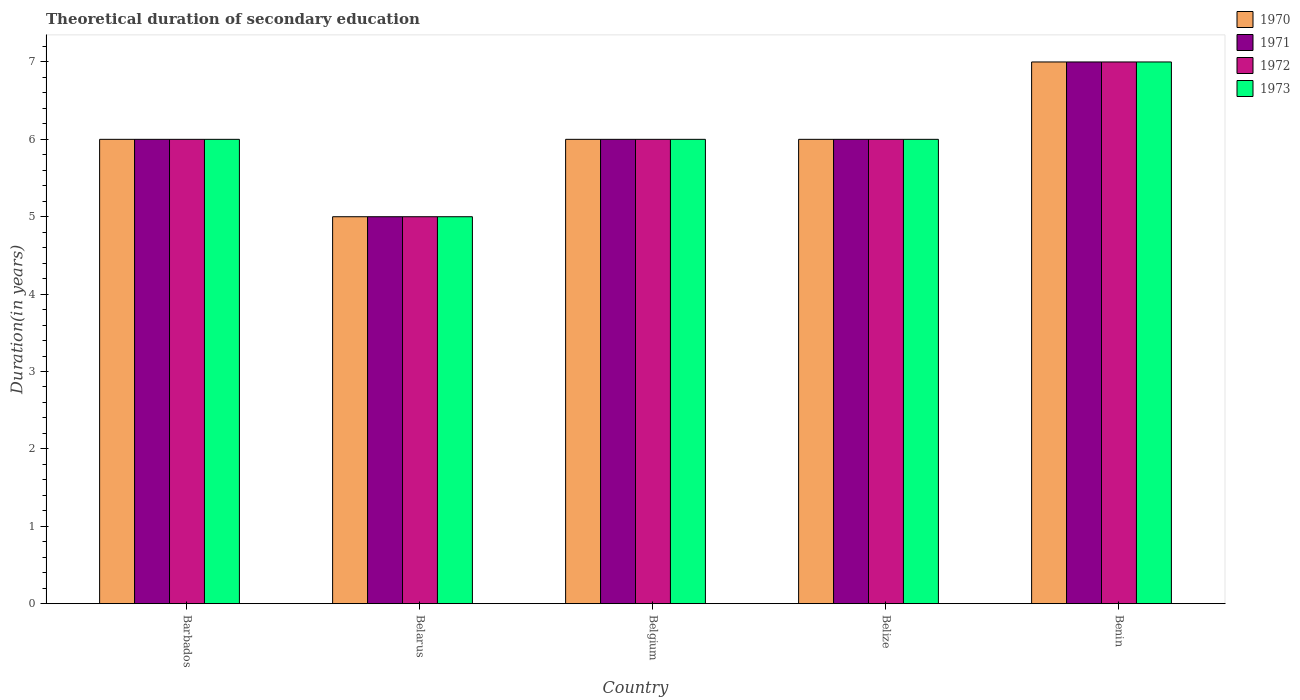How many different coloured bars are there?
Your answer should be very brief. 4. Are the number of bars on each tick of the X-axis equal?
Keep it short and to the point. Yes. How many bars are there on the 3rd tick from the left?
Give a very brief answer. 4. How many bars are there on the 2nd tick from the right?
Provide a short and direct response. 4. What is the label of the 4th group of bars from the left?
Keep it short and to the point. Belize. In how many cases, is the number of bars for a given country not equal to the number of legend labels?
Ensure brevity in your answer.  0. Across all countries, what is the minimum total theoretical duration of secondary education in 1971?
Ensure brevity in your answer.  5. In which country was the total theoretical duration of secondary education in 1971 maximum?
Offer a terse response. Benin. In which country was the total theoretical duration of secondary education in 1971 minimum?
Ensure brevity in your answer.  Belarus. What is the total total theoretical duration of secondary education in 1973 in the graph?
Give a very brief answer. 30. What is the difference between the total theoretical duration of secondary education in 1971 in Belize and that in Benin?
Your answer should be very brief. -1. What is the difference between the total theoretical duration of secondary education in 1971 in Belize and the total theoretical duration of secondary education in 1973 in Benin?
Offer a terse response. -1. What is the average total theoretical duration of secondary education in 1971 per country?
Keep it short and to the point. 6. What is the difference between the total theoretical duration of secondary education of/in 1970 and total theoretical duration of secondary education of/in 1973 in Barbados?
Give a very brief answer. 0. In how many countries, is the total theoretical duration of secondary education in 1972 greater than 1.2 years?
Offer a terse response. 5. What is the ratio of the total theoretical duration of secondary education in 1970 in Belarus to that in Benin?
Provide a short and direct response. 0.71. What is the difference between the highest and the lowest total theoretical duration of secondary education in 1970?
Provide a short and direct response. 2. In how many countries, is the total theoretical duration of secondary education in 1970 greater than the average total theoretical duration of secondary education in 1970 taken over all countries?
Your response must be concise. 1. Is the sum of the total theoretical duration of secondary education in 1973 in Belgium and Benin greater than the maximum total theoretical duration of secondary education in 1970 across all countries?
Provide a short and direct response. Yes. Is it the case that in every country, the sum of the total theoretical duration of secondary education in 1972 and total theoretical duration of secondary education in 1973 is greater than the sum of total theoretical duration of secondary education in 1971 and total theoretical duration of secondary education in 1970?
Your response must be concise. No. What does the 4th bar from the right in Belize represents?
Ensure brevity in your answer.  1970. Are all the bars in the graph horizontal?
Your answer should be compact. No. How many countries are there in the graph?
Keep it short and to the point. 5. What is the difference between two consecutive major ticks on the Y-axis?
Make the answer very short. 1. Where does the legend appear in the graph?
Your response must be concise. Top right. How many legend labels are there?
Your answer should be very brief. 4. What is the title of the graph?
Offer a very short reply. Theoretical duration of secondary education. What is the label or title of the Y-axis?
Offer a terse response. Duration(in years). What is the Duration(in years) of 1970 in Barbados?
Your answer should be compact. 6. What is the Duration(in years) in 1970 in Belarus?
Keep it short and to the point. 5. What is the Duration(in years) in 1972 in Belarus?
Keep it short and to the point. 5. What is the Duration(in years) in 1973 in Belarus?
Provide a short and direct response. 5. What is the Duration(in years) in 1972 in Belgium?
Make the answer very short. 6. What is the Duration(in years) in 1970 in Belize?
Your response must be concise. 6. What is the Duration(in years) of 1971 in Belize?
Your answer should be compact. 6. What is the Duration(in years) of 1970 in Benin?
Ensure brevity in your answer.  7. What is the Duration(in years) in 1973 in Benin?
Offer a terse response. 7. Across all countries, what is the maximum Duration(in years) of 1970?
Your response must be concise. 7. Across all countries, what is the maximum Duration(in years) in 1971?
Ensure brevity in your answer.  7. Across all countries, what is the maximum Duration(in years) of 1973?
Offer a very short reply. 7. What is the total Duration(in years) in 1970 in the graph?
Ensure brevity in your answer.  30. What is the total Duration(in years) of 1971 in the graph?
Make the answer very short. 30. What is the total Duration(in years) of 1973 in the graph?
Give a very brief answer. 30. What is the difference between the Duration(in years) of 1970 in Barbados and that in Belarus?
Make the answer very short. 1. What is the difference between the Duration(in years) in 1972 in Barbados and that in Belarus?
Offer a very short reply. 1. What is the difference between the Duration(in years) of 1973 in Barbados and that in Belarus?
Offer a terse response. 1. What is the difference between the Duration(in years) in 1971 in Barbados and that in Belgium?
Give a very brief answer. 0. What is the difference between the Duration(in years) of 1970 in Barbados and that in Belize?
Provide a succinct answer. 0. What is the difference between the Duration(in years) of 1971 in Barbados and that in Belize?
Your response must be concise. 0. What is the difference between the Duration(in years) of 1972 in Barbados and that in Belize?
Your answer should be compact. 0. What is the difference between the Duration(in years) of 1970 in Barbados and that in Benin?
Provide a succinct answer. -1. What is the difference between the Duration(in years) in 1972 in Barbados and that in Benin?
Give a very brief answer. -1. What is the difference between the Duration(in years) of 1973 in Barbados and that in Benin?
Keep it short and to the point. -1. What is the difference between the Duration(in years) of 1971 in Belarus and that in Belgium?
Your response must be concise. -1. What is the difference between the Duration(in years) of 1970 in Belarus and that in Belize?
Provide a short and direct response. -1. What is the difference between the Duration(in years) in 1971 in Belarus and that in Belize?
Your answer should be very brief. -1. What is the difference between the Duration(in years) of 1972 in Belarus and that in Belize?
Provide a succinct answer. -1. What is the difference between the Duration(in years) of 1971 in Belarus and that in Benin?
Provide a short and direct response. -2. What is the difference between the Duration(in years) in 1973 in Belarus and that in Benin?
Ensure brevity in your answer.  -2. What is the difference between the Duration(in years) in 1970 in Belgium and that in Belize?
Make the answer very short. 0. What is the difference between the Duration(in years) of 1971 in Belgium and that in Benin?
Your answer should be compact. -1. What is the difference between the Duration(in years) of 1970 in Belize and that in Benin?
Offer a very short reply. -1. What is the difference between the Duration(in years) of 1972 in Belize and that in Benin?
Keep it short and to the point. -1. What is the difference between the Duration(in years) in 1973 in Belize and that in Benin?
Offer a terse response. -1. What is the difference between the Duration(in years) of 1970 in Barbados and the Duration(in years) of 1971 in Belarus?
Provide a succinct answer. 1. What is the difference between the Duration(in years) in 1970 in Barbados and the Duration(in years) in 1973 in Belarus?
Your answer should be very brief. 1. What is the difference between the Duration(in years) of 1971 in Barbados and the Duration(in years) of 1973 in Belarus?
Provide a succinct answer. 1. What is the difference between the Duration(in years) in 1970 in Barbados and the Duration(in years) in 1972 in Belgium?
Keep it short and to the point. 0. What is the difference between the Duration(in years) of 1971 in Barbados and the Duration(in years) of 1972 in Belgium?
Provide a succinct answer. 0. What is the difference between the Duration(in years) of 1970 in Barbados and the Duration(in years) of 1971 in Belize?
Provide a succinct answer. 0. What is the difference between the Duration(in years) of 1971 in Barbados and the Duration(in years) of 1973 in Belize?
Provide a short and direct response. 0. What is the difference between the Duration(in years) in 1972 in Barbados and the Duration(in years) in 1973 in Belize?
Give a very brief answer. 0. What is the difference between the Duration(in years) of 1970 in Barbados and the Duration(in years) of 1971 in Benin?
Provide a short and direct response. -1. What is the difference between the Duration(in years) in 1970 in Barbados and the Duration(in years) in 1972 in Benin?
Your answer should be very brief. -1. What is the difference between the Duration(in years) in 1970 in Barbados and the Duration(in years) in 1973 in Benin?
Offer a terse response. -1. What is the difference between the Duration(in years) of 1971 in Barbados and the Duration(in years) of 1973 in Benin?
Keep it short and to the point. -1. What is the difference between the Duration(in years) in 1970 in Belarus and the Duration(in years) in 1971 in Belgium?
Provide a succinct answer. -1. What is the difference between the Duration(in years) in 1970 in Belarus and the Duration(in years) in 1972 in Belgium?
Offer a very short reply. -1. What is the difference between the Duration(in years) of 1971 in Belarus and the Duration(in years) of 1973 in Belize?
Provide a succinct answer. -1. What is the difference between the Duration(in years) in 1972 in Belarus and the Duration(in years) in 1973 in Belize?
Keep it short and to the point. -1. What is the difference between the Duration(in years) in 1970 in Belarus and the Duration(in years) in 1971 in Benin?
Provide a succinct answer. -2. What is the difference between the Duration(in years) in 1971 in Belarus and the Duration(in years) in 1972 in Benin?
Your answer should be compact. -2. What is the difference between the Duration(in years) of 1971 in Belarus and the Duration(in years) of 1973 in Benin?
Offer a terse response. -2. What is the difference between the Duration(in years) of 1970 in Belgium and the Duration(in years) of 1973 in Belize?
Make the answer very short. 0. What is the difference between the Duration(in years) in 1971 in Belgium and the Duration(in years) in 1972 in Belize?
Provide a succinct answer. 0. What is the difference between the Duration(in years) in 1971 in Belgium and the Duration(in years) in 1973 in Belize?
Keep it short and to the point. 0. What is the difference between the Duration(in years) of 1972 in Belgium and the Duration(in years) of 1973 in Belize?
Ensure brevity in your answer.  0. What is the difference between the Duration(in years) of 1970 in Belgium and the Duration(in years) of 1973 in Benin?
Make the answer very short. -1. What is the difference between the Duration(in years) in 1972 in Belgium and the Duration(in years) in 1973 in Benin?
Your answer should be very brief. -1. What is the difference between the Duration(in years) in 1970 in Belize and the Duration(in years) in 1971 in Benin?
Offer a very short reply. -1. What is the difference between the Duration(in years) in 1970 in Belize and the Duration(in years) in 1972 in Benin?
Your response must be concise. -1. What is the difference between the Duration(in years) of 1970 in Belize and the Duration(in years) of 1973 in Benin?
Provide a short and direct response. -1. What is the difference between the Duration(in years) of 1971 in Belize and the Duration(in years) of 1973 in Benin?
Provide a succinct answer. -1. What is the difference between the Duration(in years) of 1972 in Belize and the Duration(in years) of 1973 in Benin?
Provide a succinct answer. -1. What is the average Duration(in years) of 1970 per country?
Your answer should be very brief. 6. What is the difference between the Duration(in years) of 1970 and Duration(in years) of 1973 in Barbados?
Your answer should be compact. 0. What is the difference between the Duration(in years) in 1970 and Duration(in years) in 1971 in Belarus?
Offer a terse response. 0. What is the difference between the Duration(in years) in 1970 and Duration(in years) in 1973 in Belarus?
Provide a succinct answer. 0. What is the difference between the Duration(in years) of 1970 and Duration(in years) of 1971 in Belgium?
Give a very brief answer. 0. What is the difference between the Duration(in years) of 1970 and Duration(in years) of 1973 in Belgium?
Your response must be concise. 0. What is the difference between the Duration(in years) in 1970 and Duration(in years) in 1971 in Belize?
Provide a succinct answer. 0. What is the difference between the Duration(in years) in 1970 and Duration(in years) in 1972 in Belize?
Your response must be concise. 0. What is the difference between the Duration(in years) in 1971 and Duration(in years) in 1972 in Belize?
Provide a succinct answer. 0. What is the difference between the Duration(in years) in 1971 and Duration(in years) in 1973 in Belize?
Make the answer very short. 0. What is the difference between the Duration(in years) of 1972 and Duration(in years) of 1973 in Belize?
Give a very brief answer. 0. What is the difference between the Duration(in years) of 1970 and Duration(in years) of 1972 in Benin?
Provide a succinct answer. 0. What is the difference between the Duration(in years) of 1971 and Duration(in years) of 1973 in Benin?
Offer a terse response. 0. What is the ratio of the Duration(in years) of 1972 in Barbados to that in Belarus?
Your answer should be compact. 1.2. What is the ratio of the Duration(in years) in 1973 in Barbados to that in Belarus?
Offer a very short reply. 1.2. What is the ratio of the Duration(in years) of 1971 in Barbados to that in Belgium?
Give a very brief answer. 1. What is the ratio of the Duration(in years) of 1973 in Barbados to that in Belgium?
Give a very brief answer. 1. What is the ratio of the Duration(in years) in 1971 in Barbados to that in Belize?
Keep it short and to the point. 1. What is the ratio of the Duration(in years) of 1970 in Barbados to that in Benin?
Provide a succinct answer. 0.86. What is the ratio of the Duration(in years) of 1971 in Barbados to that in Benin?
Provide a succinct answer. 0.86. What is the ratio of the Duration(in years) in 1972 in Barbados to that in Benin?
Your response must be concise. 0.86. What is the ratio of the Duration(in years) in 1970 in Belarus to that in Belgium?
Provide a succinct answer. 0.83. What is the ratio of the Duration(in years) of 1971 in Belarus to that in Belgium?
Offer a very short reply. 0.83. What is the ratio of the Duration(in years) of 1972 in Belarus to that in Belgium?
Make the answer very short. 0.83. What is the ratio of the Duration(in years) of 1971 in Belarus to that in Belize?
Provide a succinct answer. 0.83. What is the ratio of the Duration(in years) of 1973 in Belarus to that in Belize?
Provide a succinct answer. 0.83. What is the ratio of the Duration(in years) in 1970 in Belarus to that in Benin?
Offer a terse response. 0.71. What is the ratio of the Duration(in years) of 1971 in Belarus to that in Benin?
Make the answer very short. 0.71. What is the ratio of the Duration(in years) in 1972 in Belarus to that in Benin?
Offer a very short reply. 0.71. What is the ratio of the Duration(in years) in 1970 in Belgium to that in Belize?
Provide a succinct answer. 1. What is the ratio of the Duration(in years) of 1971 in Belgium to that in Belize?
Offer a very short reply. 1. What is the ratio of the Duration(in years) of 1972 in Belgium to that in Belize?
Ensure brevity in your answer.  1. What is the ratio of the Duration(in years) in 1970 in Belgium to that in Benin?
Your response must be concise. 0.86. What is the ratio of the Duration(in years) of 1971 in Belgium to that in Benin?
Provide a short and direct response. 0.86. What is the ratio of the Duration(in years) of 1972 in Belgium to that in Benin?
Offer a terse response. 0.86. What is the difference between the highest and the second highest Duration(in years) of 1971?
Ensure brevity in your answer.  1. 